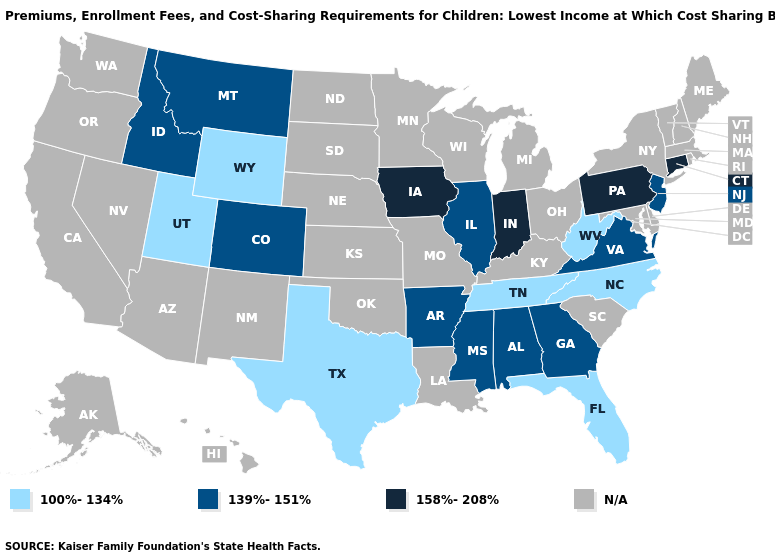What is the highest value in the South ?
Give a very brief answer. 139%-151%. Name the states that have a value in the range 139%-151%?
Write a very short answer. Alabama, Arkansas, Colorado, Georgia, Idaho, Illinois, Mississippi, Montana, New Jersey, Virginia. What is the value of Colorado?
Keep it brief. 139%-151%. What is the lowest value in the West?
Quick response, please. 100%-134%. What is the lowest value in states that border Washington?
Quick response, please. 139%-151%. Which states have the lowest value in the Northeast?
Write a very short answer. New Jersey. Is the legend a continuous bar?
Give a very brief answer. No. What is the lowest value in the USA?
Be succinct. 100%-134%. Does the map have missing data?
Concise answer only. Yes. Name the states that have a value in the range 158%-208%?
Keep it brief. Connecticut, Indiana, Iowa, Pennsylvania. Name the states that have a value in the range N/A?
Quick response, please. Alaska, Arizona, California, Delaware, Hawaii, Kansas, Kentucky, Louisiana, Maine, Maryland, Massachusetts, Michigan, Minnesota, Missouri, Nebraska, Nevada, New Hampshire, New Mexico, New York, North Dakota, Ohio, Oklahoma, Oregon, Rhode Island, South Carolina, South Dakota, Vermont, Washington, Wisconsin. What is the lowest value in the USA?
Keep it brief. 100%-134%. Which states have the lowest value in the West?
Quick response, please. Utah, Wyoming. Does the first symbol in the legend represent the smallest category?
Be succinct. Yes. Which states hav the highest value in the West?
Be succinct. Colorado, Idaho, Montana. 